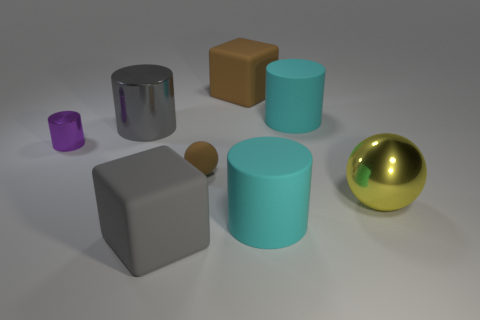What number of objects are large cyan matte things or large yellow metal spheres to the right of the gray block?
Your response must be concise. 3. What is the size of the cube that is the same color as the small ball?
Ensure brevity in your answer.  Large. What is the shape of the large cyan thing in front of the big gray cylinder?
Keep it short and to the point. Cylinder. Does the large matte cube that is left of the large brown rubber cube have the same color as the big ball?
Make the answer very short. No. What material is the big block that is the same color as the big shiny cylinder?
Offer a terse response. Rubber. Does the gray metallic cylinder that is in front of the brown cube have the same size as the big gray rubber block?
Your answer should be very brief. Yes. Is there a tiny metallic block of the same color as the tiny metallic thing?
Your answer should be very brief. No. Are there any small shiny cylinders behind the large gray thing that is behind the tiny brown matte object?
Provide a short and direct response. No. Is there a cube that has the same material as the big gray cylinder?
Your answer should be very brief. No. What is the material of the large gray thing that is behind the rubber cube in front of the tiny brown rubber ball?
Provide a short and direct response. Metal. 